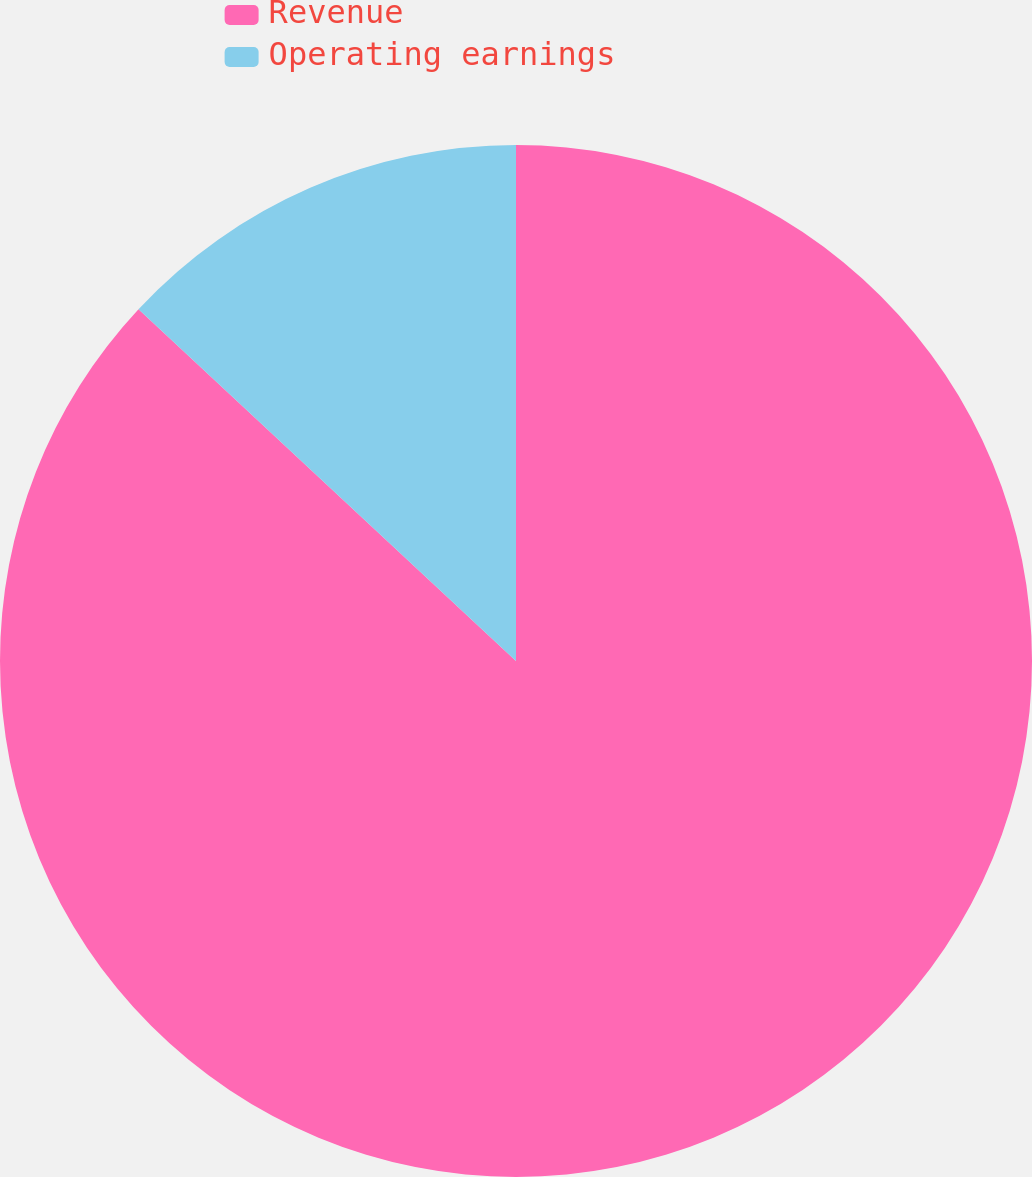Convert chart. <chart><loc_0><loc_0><loc_500><loc_500><pie_chart><fcel>Revenue<fcel>Operating earnings<nl><fcel>86.94%<fcel>13.06%<nl></chart> 